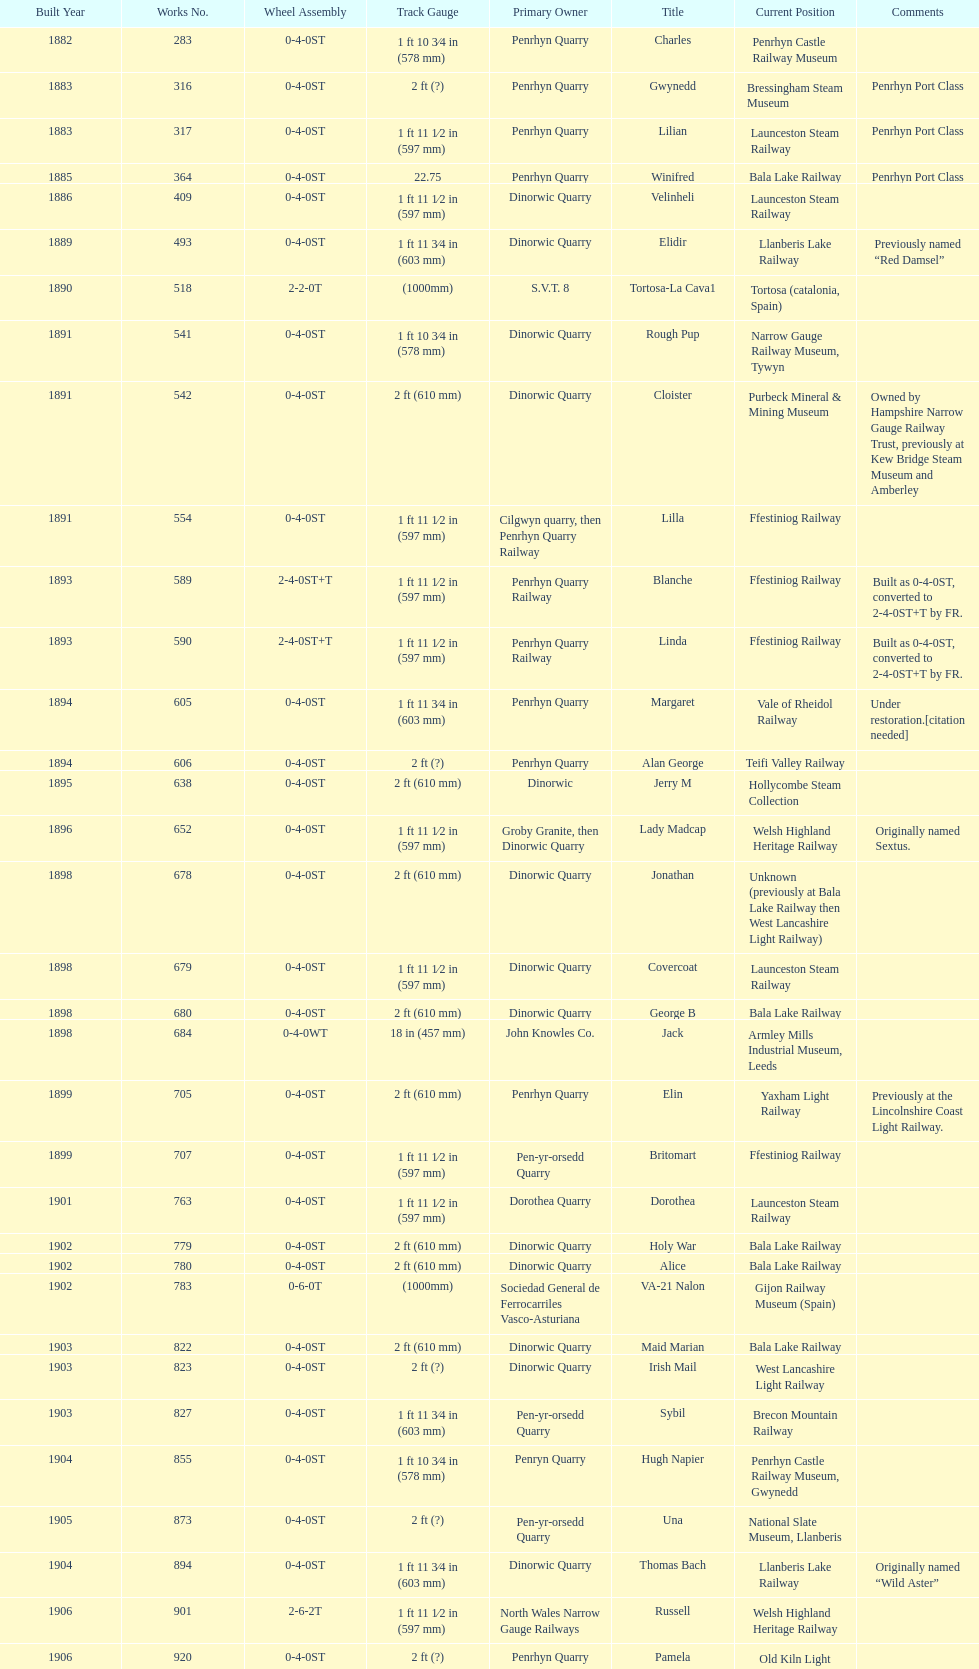I'm looking to parse the entire table for insights. Could you assist me with that? {'header': ['Built Year', 'Works No.', 'Wheel Assembly', 'Track Gauge', 'Primary Owner', 'Title', 'Current Position', 'Comments'], 'rows': [['1882', '283', '0-4-0ST', '1\xa0ft 10\xa03⁄4\xa0in (578\xa0mm)', 'Penrhyn Quarry', 'Charles', 'Penrhyn Castle Railway Museum', ''], ['1883', '316', '0-4-0ST', '2\xa0ft (?)', 'Penrhyn Quarry', 'Gwynedd', 'Bressingham Steam Museum', 'Penrhyn Port Class'], ['1883', '317', '0-4-0ST', '1\xa0ft 11\xa01⁄2\xa0in (597\xa0mm)', 'Penrhyn Quarry', 'Lilian', 'Launceston Steam Railway', 'Penrhyn Port Class'], ['1885', '364', '0-4-0ST', '22.75', 'Penrhyn Quarry', 'Winifred', 'Bala Lake Railway', 'Penrhyn Port Class'], ['1886', '409', '0-4-0ST', '1\xa0ft 11\xa01⁄2\xa0in (597\xa0mm)', 'Dinorwic Quarry', 'Velinheli', 'Launceston Steam Railway', ''], ['1889', '493', '0-4-0ST', '1\xa0ft 11\xa03⁄4\xa0in (603\xa0mm)', 'Dinorwic Quarry', 'Elidir', 'Llanberis Lake Railway', 'Previously named “Red Damsel”'], ['1890', '518', '2-2-0T', '(1000mm)', 'S.V.T. 8', 'Tortosa-La Cava1', 'Tortosa (catalonia, Spain)', ''], ['1891', '541', '0-4-0ST', '1\xa0ft 10\xa03⁄4\xa0in (578\xa0mm)', 'Dinorwic Quarry', 'Rough Pup', 'Narrow Gauge Railway Museum, Tywyn', ''], ['1891', '542', '0-4-0ST', '2\xa0ft (610\xa0mm)', 'Dinorwic Quarry', 'Cloister', 'Purbeck Mineral & Mining Museum', 'Owned by Hampshire Narrow Gauge Railway Trust, previously at Kew Bridge Steam Museum and Amberley'], ['1891', '554', '0-4-0ST', '1\xa0ft 11\xa01⁄2\xa0in (597\xa0mm)', 'Cilgwyn quarry, then Penrhyn Quarry Railway', 'Lilla', 'Ffestiniog Railway', ''], ['1893', '589', '2-4-0ST+T', '1\xa0ft 11\xa01⁄2\xa0in (597\xa0mm)', 'Penrhyn Quarry Railway', 'Blanche', 'Ffestiniog Railway', 'Built as 0-4-0ST, converted to 2-4-0ST+T by FR.'], ['1893', '590', '2-4-0ST+T', '1\xa0ft 11\xa01⁄2\xa0in (597\xa0mm)', 'Penrhyn Quarry Railway', 'Linda', 'Ffestiniog Railway', 'Built as 0-4-0ST, converted to 2-4-0ST+T by FR.'], ['1894', '605', '0-4-0ST', '1\xa0ft 11\xa03⁄4\xa0in (603\xa0mm)', 'Penrhyn Quarry', 'Margaret', 'Vale of Rheidol Railway', 'Under restoration.[citation needed]'], ['1894', '606', '0-4-0ST', '2\xa0ft (?)', 'Penrhyn Quarry', 'Alan George', 'Teifi Valley Railway', ''], ['1895', '638', '0-4-0ST', '2\xa0ft (610\xa0mm)', 'Dinorwic', 'Jerry M', 'Hollycombe Steam Collection', ''], ['1896', '652', '0-4-0ST', '1\xa0ft 11\xa01⁄2\xa0in (597\xa0mm)', 'Groby Granite, then Dinorwic Quarry', 'Lady Madcap', 'Welsh Highland Heritage Railway', 'Originally named Sextus.'], ['1898', '678', '0-4-0ST', '2\xa0ft (610\xa0mm)', 'Dinorwic Quarry', 'Jonathan', 'Unknown (previously at Bala Lake Railway then West Lancashire Light Railway)', ''], ['1898', '679', '0-4-0ST', '1\xa0ft 11\xa01⁄2\xa0in (597\xa0mm)', 'Dinorwic Quarry', 'Covercoat', 'Launceston Steam Railway', ''], ['1898', '680', '0-4-0ST', '2\xa0ft (610\xa0mm)', 'Dinorwic Quarry', 'George B', 'Bala Lake Railway', ''], ['1898', '684', '0-4-0WT', '18\xa0in (457\xa0mm)', 'John Knowles Co.', 'Jack', 'Armley Mills Industrial Museum, Leeds', ''], ['1899', '705', '0-4-0ST', '2\xa0ft (610\xa0mm)', 'Penrhyn Quarry', 'Elin', 'Yaxham Light Railway', 'Previously at the Lincolnshire Coast Light Railway.'], ['1899', '707', '0-4-0ST', '1\xa0ft 11\xa01⁄2\xa0in (597\xa0mm)', 'Pen-yr-orsedd Quarry', 'Britomart', 'Ffestiniog Railway', ''], ['1901', '763', '0-4-0ST', '1\xa0ft 11\xa01⁄2\xa0in (597\xa0mm)', 'Dorothea Quarry', 'Dorothea', 'Launceston Steam Railway', ''], ['1902', '779', '0-4-0ST', '2\xa0ft (610\xa0mm)', 'Dinorwic Quarry', 'Holy War', 'Bala Lake Railway', ''], ['1902', '780', '0-4-0ST', '2\xa0ft (610\xa0mm)', 'Dinorwic Quarry', 'Alice', 'Bala Lake Railway', ''], ['1902', '783', '0-6-0T', '(1000mm)', 'Sociedad General de Ferrocarriles Vasco-Asturiana', 'VA-21 Nalon', 'Gijon Railway Museum (Spain)', ''], ['1903', '822', '0-4-0ST', '2\xa0ft (610\xa0mm)', 'Dinorwic Quarry', 'Maid Marian', 'Bala Lake Railway', ''], ['1903', '823', '0-4-0ST', '2\xa0ft (?)', 'Dinorwic Quarry', 'Irish Mail', 'West Lancashire Light Railway', ''], ['1903', '827', '0-4-0ST', '1\xa0ft 11\xa03⁄4\xa0in (603\xa0mm)', 'Pen-yr-orsedd Quarry', 'Sybil', 'Brecon Mountain Railway', ''], ['1904', '855', '0-4-0ST', '1\xa0ft 10\xa03⁄4\xa0in (578\xa0mm)', 'Penryn Quarry', 'Hugh Napier', 'Penrhyn Castle Railway Museum, Gwynedd', ''], ['1905', '873', '0-4-0ST', '2\xa0ft (?)', 'Pen-yr-orsedd Quarry', 'Una', 'National Slate Museum, Llanberis', ''], ['1904', '894', '0-4-0ST', '1\xa0ft 11\xa03⁄4\xa0in (603\xa0mm)', 'Dinorwic Quarry', 'Thomas Bach', 'Llanberis Lake Railway', 'Originally named “Wild Aster”'], ['1906', '901', '2-6-2T', '1\xa0ft 11\xa01⁄2\xa0in (597\xa0mm)', 'North Wales Narrow Gauge Railways', 'Russell', 'Welsh Highland Heritage Railway', ''], ['1906', '920', '0-4-0ST', '2\xa0ft (?)', 'Penrhyn Quarry', 'Pamela', 'Old Kiln Light Railway', ''], ['1909', '994', '0-4-0ST', '2\xa0ft (?)', 'Penrhyn Quarry', 'Bill Harvey', 'Bressingham Steam Museum', 'previously George Sholto'], ['1918', '1312', '4-6-0T', '1\xa0ft\xa011\xa01⁄2\xa0in (597\xa0mm)', 'British War Department\\nEFOP #203', '---', 'Pampas Safari, Gravataí, RS, Brazil', '[citation needed]'], ['1918\\nor\\n1921?', '1313', '0-6-2T', '3\xa0ft\xa03\xa03⁄8\xa0in (1,000\xa0mm)', 'British War Department\\nUsina Leão Utinga #1\\nUsina Laginha #1', '---', 'Usina Laginha, União dos Palmares, AL, Brazil', '[citation needed]'], ['1920', '1404', '0-4-0WT', '18\xa0in (457\xa0mm)', 'John Knowles Co.', 'Gwen', 'Richard Farmer current owner, Northridge, California, USA', ''], ['1922', '1429', '0-4-0ST', '2\xa0ft (610\xa0mm)', 'Dinorwic', 'Lady Joan', 'Bredgar and Wormshill Light Railway', ''], ['1922', '1430', '0-4-0ST', '1\xa0ft 11\xa03⁄4\xa0in (603\xa0mm)', 'Dinorwic Quarry', 'Dolbadarn', 'Llanberis Lake Railway', ''], ['1937', '1859', '0-4-2T', '2\xa0ft (?)', 'Umtwalumi Valley Estate, Natal', '16 Carlisle', 'South Tynedale Railway', ''], ['1940', '2075', '0-4-2T', '2\xa0ft (?)', 'Chaka’s Kraal Sugar Estates, Natal', 'Chaka’s Kraal No. 6', 'North Gloucestershire Railway', ''], ['1954', '3815', '2-6-2T', '2\xa0ft 6\xa0in (762\xa0mm)', 'Sierra Leone Government Railway', '14', 'Welshpool and Llanfair Light Railway', ''], ['1971', '3902', '0-4-2ST', '2\xa0ft (610\xa0mm)', 'Trangkil Sugar Mill, Indonesia', 'Trangkil No.4', 'Statfold Barn Railway', 'Converted from 750\xa0mm (2\xa0ft\xa05\xa01⁄2\xa0in) gauge. Last steam locomotive to be built by Hunslet, and the last industrial steam locomotive built in Britain.']]} In which year were the most steam locomotives built? 1898. 